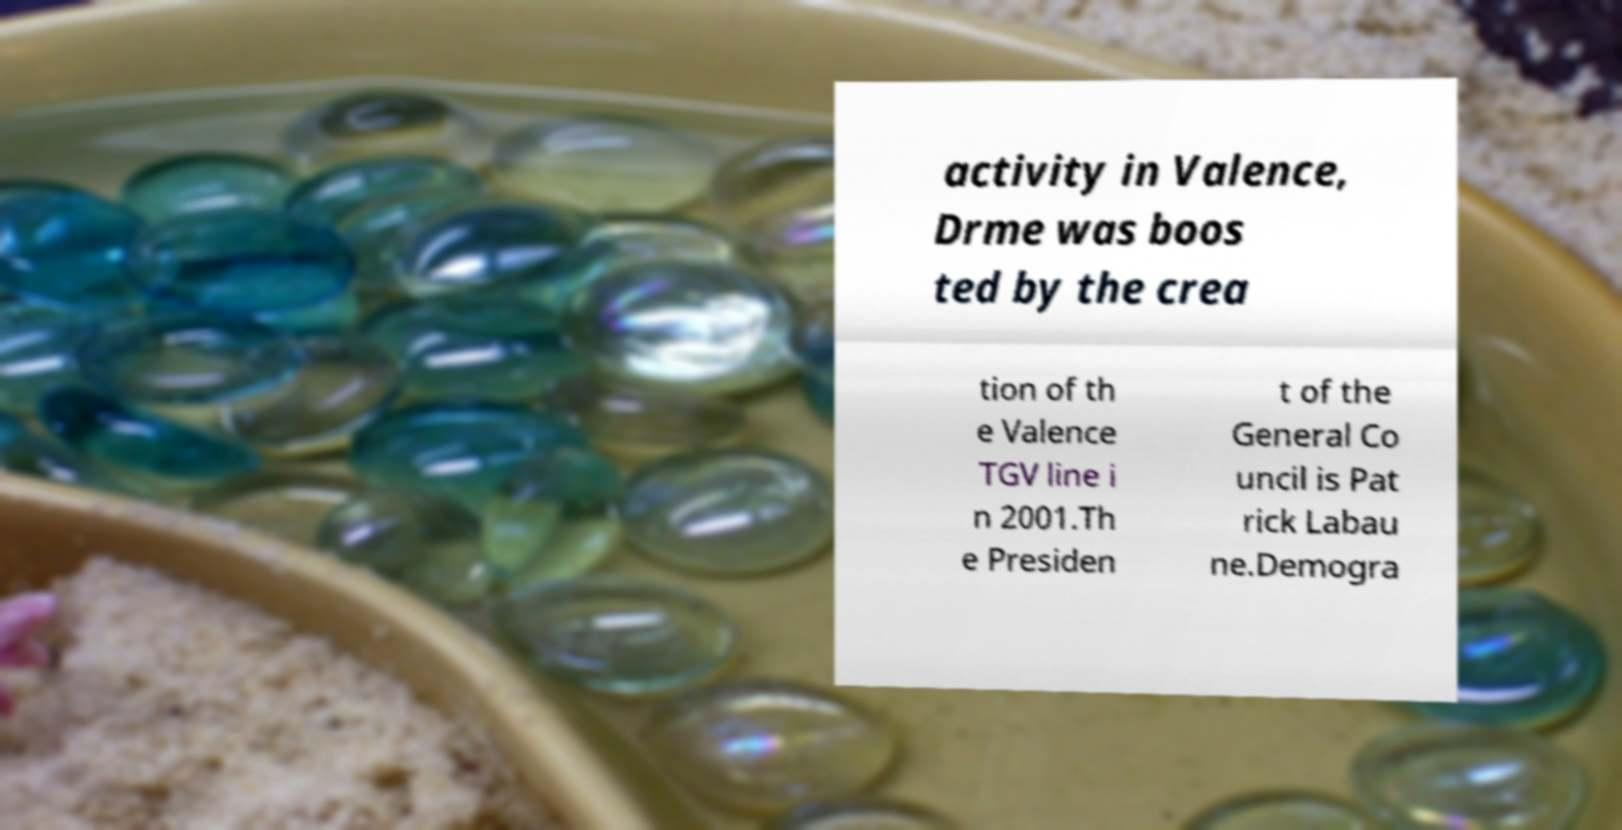What messages or text are displayed in this image? I need them in a readable, typed format. activity in Valence, Drme was boos ted by the crea tion of th e Valence TGV line i n 2001.Th e Presiden t of the General Co uncil is Pat rick Labau ne.Demogra 